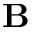<formula> <loc_0><loc_0><loc_500><loc_500>B</formula> 